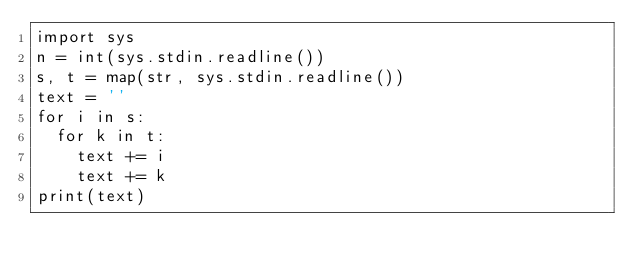<code> <loc_0><loc_0><loc_500><loc_500><_Python_>import sys
n = int(sys.stdin.readline())
s, t = map(str, sys.stdin.readline())
text = ''
for i in s:
  for k in t:
    text += i
    text += k
print(text)</code> 